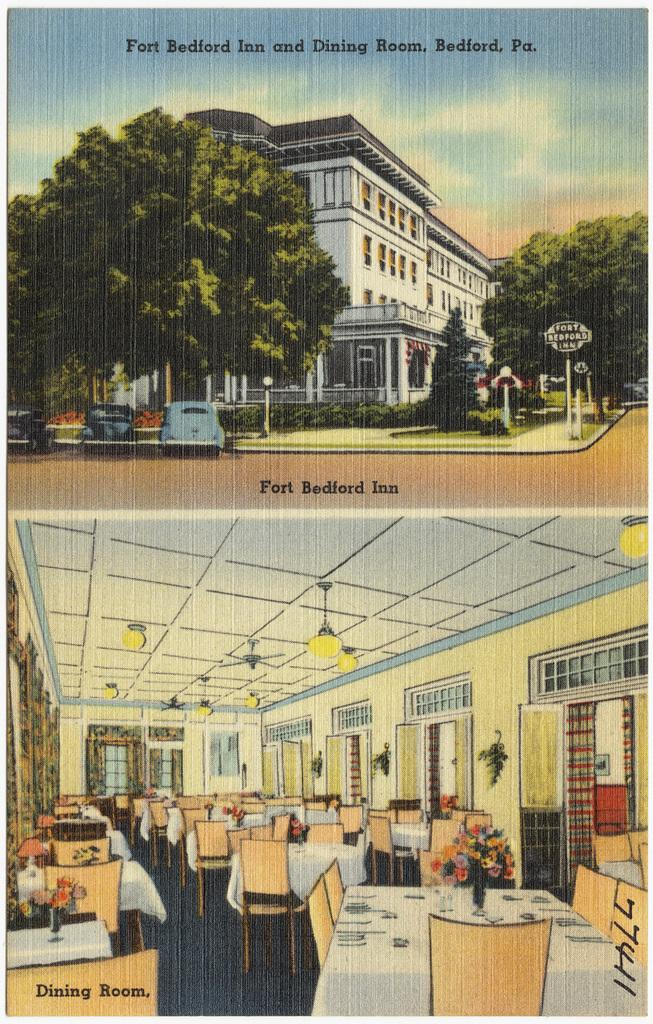<image>
Give a short and clear explanation of the subsequent image. Cartoon drawing of Fort Bedford Inn and Dining Room outside and dining area. 